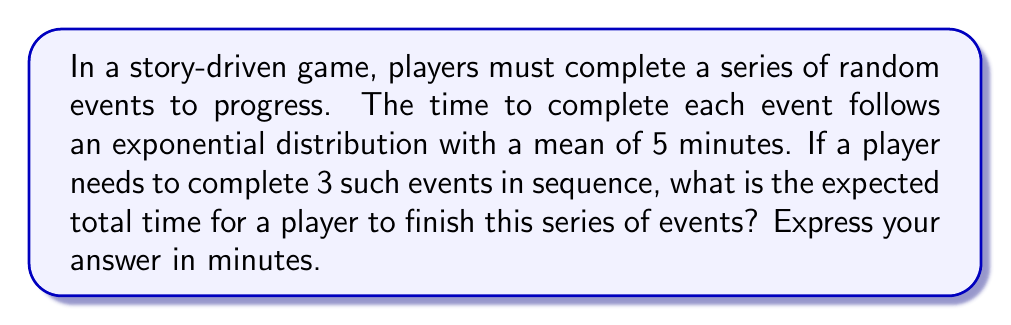Teach me how to tackle this problem. Let's approach this problem using renewal process theory:

1) Each event completion can be considered a renewal, and the series of events forms a renewal process.

2) The time between renewals (event completions) follows an exponential distribution with mean $\lambda = 5$ minutes.

3) We need to find the expected time for 3 such events to occur.

4) For exponential distributions, the inter-arrival times are independent and identically distributed (i.i.d.).

5) Let $X_i$ be the time for the $i$-th event. Then:

   $E[X_i] = 5$ minutes for all $i$

6) The total time $T$ for completing 3 events is:

   $T = X_1 + X_2 + X_3$

7) By the linearity of expectation:

   $E[T] = E[X_1 + X_2 + X_3] = E[X_1] + E[X_2] + E[X_3]$

8) Since all $X_i$ have the same expectation:

   $E[T] = 5 + 5 + 5 = 15$ minutes

Therefore, the expected total time for a player to complete the series of 3 events is 15 minutes.
Answer: 15 minutes 